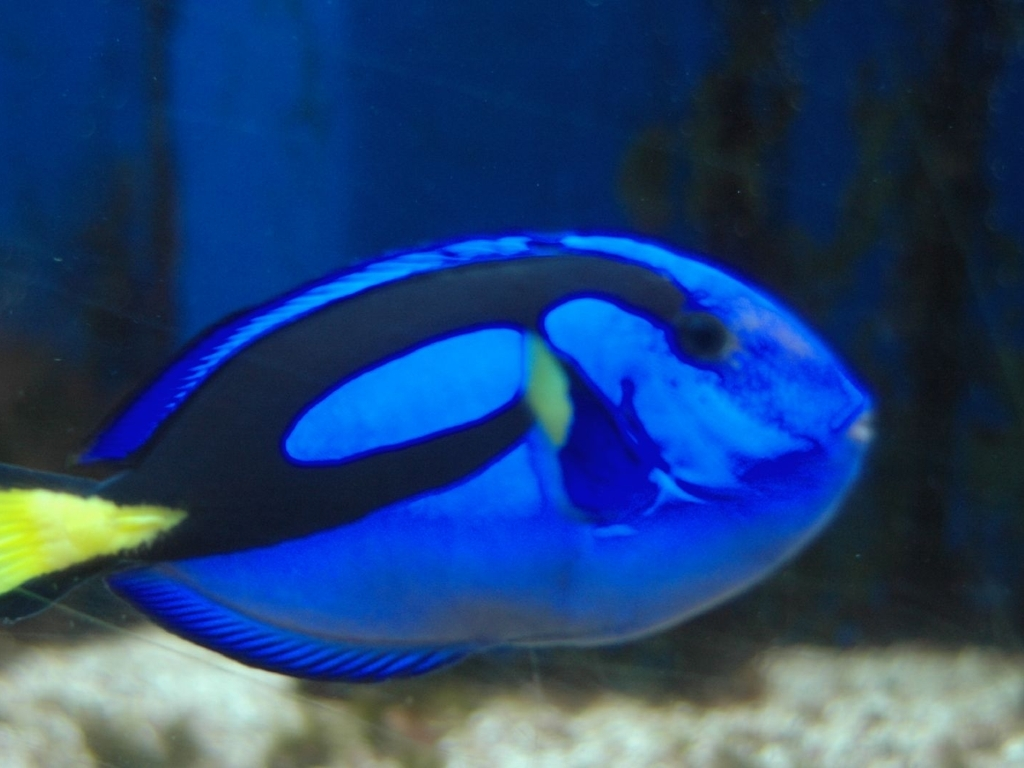What species of fish is shown in the picture? The fish in the picture is a blue tang, also known scientifically as Paracanthurus hepatus. It's distinguished by its bright blue body, bold black markings, and a yellow tail. 